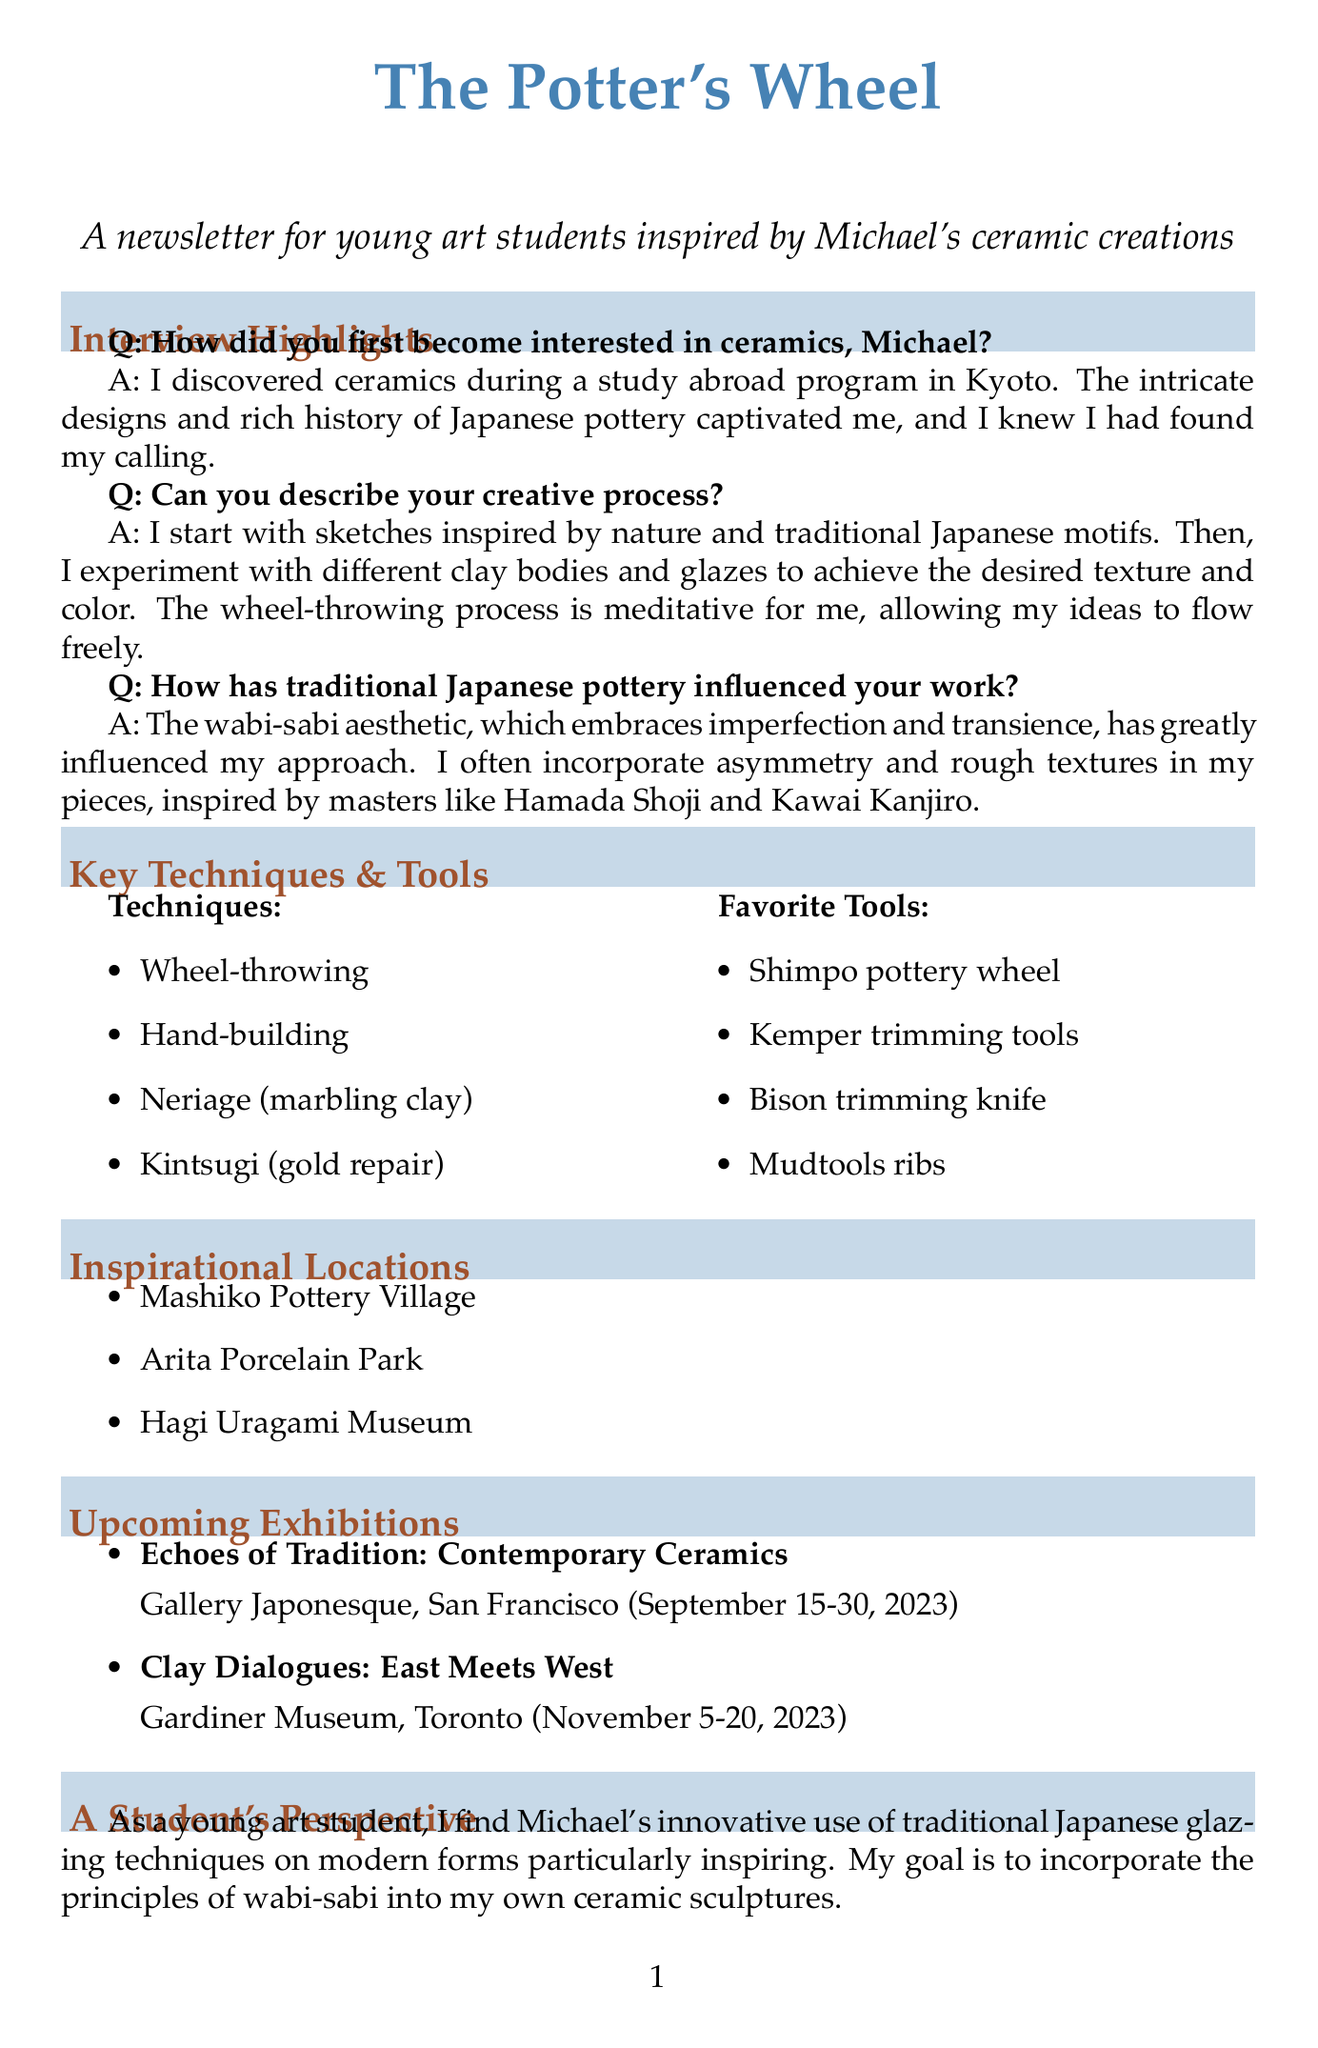How did Michael first become interested in ceramics? Michael became interested in ceramics during a study abroad program in Kyoto.
Answer: study abroad program in Kyoto What is the primary aesthetic that influences Michael's work? The primary aesthetic that influences Michael's work is wabi-sabi.
Answer: wabi-sabi What is one of the techniques Michael uses in his pottery? One of the techniques mentioned is Kintsugi.
Answer: Kintsugi What is the name of Michael's upcoming exhibition in Toronto? The name of the exhibition in Toronto is "Clay Dialogues: East Meets West".
Answer: Clay Dialogues: East Meets West What is Michael's favorite aspect of glazing techniques? Michael's favorite aspect is the innovative use of traditional Japanese glazing techniques on modern forms.
Answer: innovative use of traditional Japanese glazing techniques on modern forms How long is the exhibition "Echoes of Tradition: Contemporary Ceramics"? The exhibition lasts for 15 days from September 15 to September 30, 2023.
Answer: 15 days Who is the author of "The Unknown Craftsman: A Japanese Insight into Beauty"? The author of the book is Soetsu Yanagi.
Answer: Soetsu Yanagi What city is the Gallery Japonesque located in? The Gallery Japonesque is located in San Francisco.
Answer: San Francisco What does Michael consider his creative process to be? Michael considers his creative process to be meditative.
Answer: meditative 